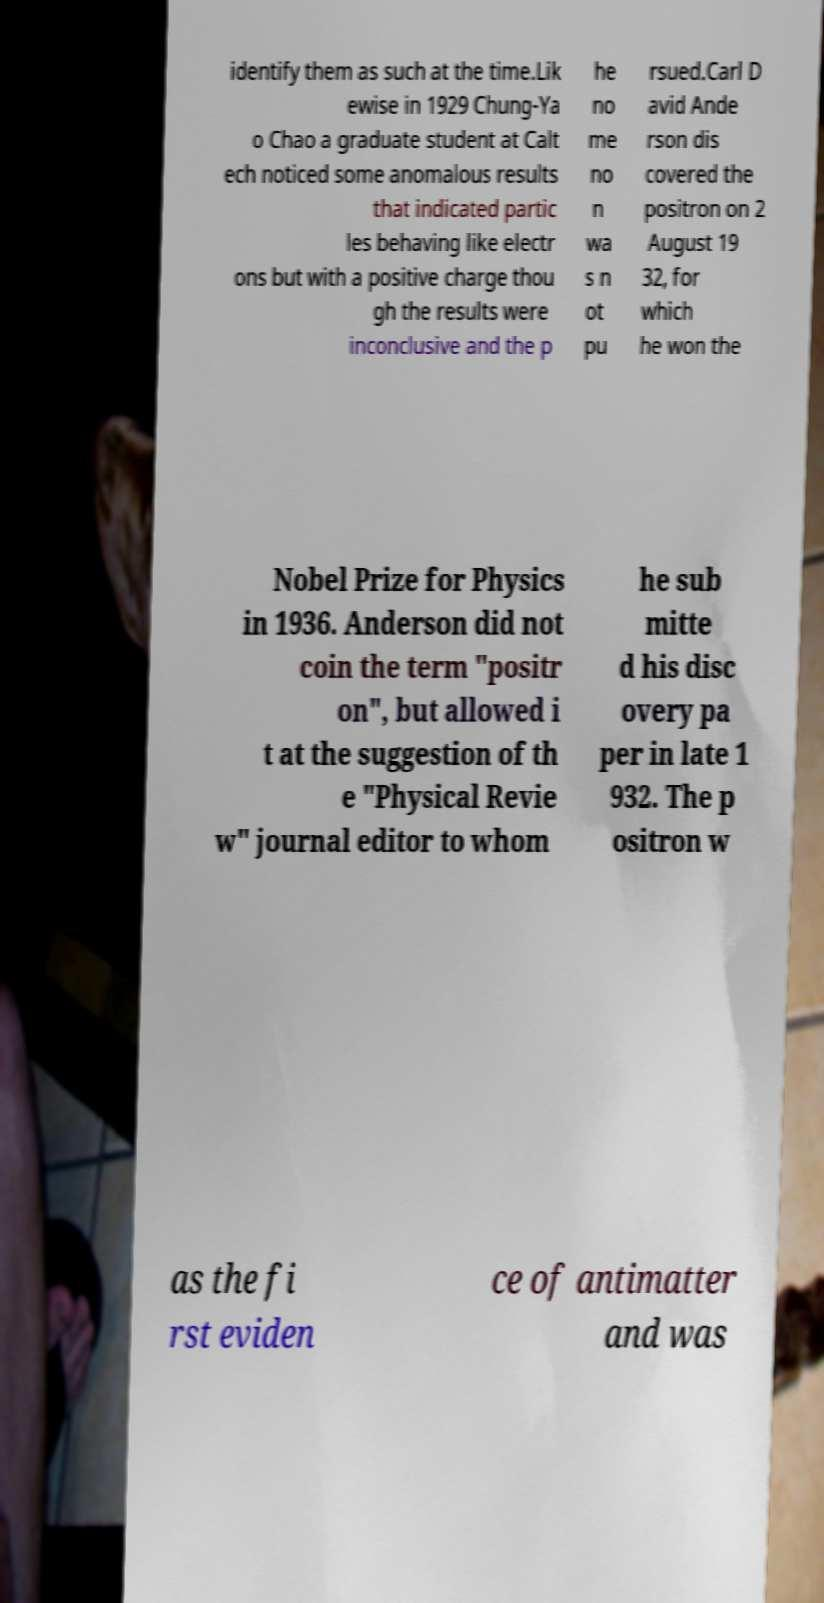What messages or text are displayed in this image? I need them in a readable, typed format. identify them as such at the time.Lik ewise in 1929 Chung-Ya o Chao a graduate student at Calt ech noticed some anomalous results that indicated partic les behaving like electr ons but with a positive charge thou gh the results were inconclusive and the p he no me no n wa s n ot pu rsued.Carl D avid Ande rson dis covered the positron on 2 August 19 32, for which he won the Nobel Prize for Physics in 1936. Anderson did not coin the term "positr on", but allowed i t at the suggestion of th e "Physical Revie w" journal editor to whom he sub mitte d his disc overy pa per in late 1 932. The p ositron w as the fi rst eviden ce of antimatter and was 